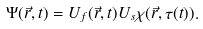<formula> <loc_0><loc_0><loc_500><loc_500>\Psi ( \vec { r } , t ) = U _ { f } ( \vec { r } , t ) U _ { s } \chi ( \vec { r } , \tau ( t ) ) .</formula> 